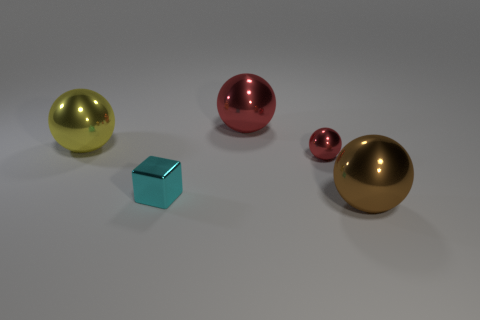Subtract all brown cylinders. How many red balls are left? 2 Add 2 metallic objects. How many objects exist? 7 Subtract all small metal balls. How many balls are left? 3 Subtract 2 spheres. How many spheres are left? 2 Subtract all brown spheres. How many spheres are left? 3 Subtract all balls. How many objects are left? 1 Add 2 large shiny objects. How many large shiny objects are left? 5 Add 4 yellow metal things. How many yellow metal things exist? 5 Subtract 0 purple cylinders. How many objects are left? 5 Subtract all blue blocks. Subtract all green spheres. How many blocks are left? 1 